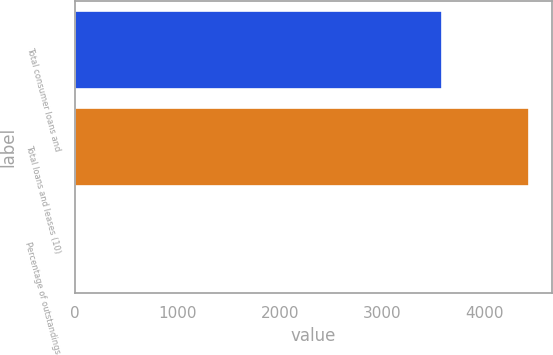<chart> <loc_0><loc_0><loc_500><loc_500><bar_chart><fcel>Total consumer loans and<fcel>Total loans and leases (10)<fcel>Percentage of outstandings<nl><fcel>3581<fcel>4433<fcel>0.48<nl></chart> 